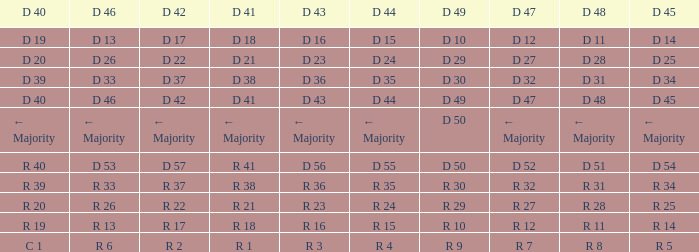I want the D 45 and D 42 of r 22 R 25. 